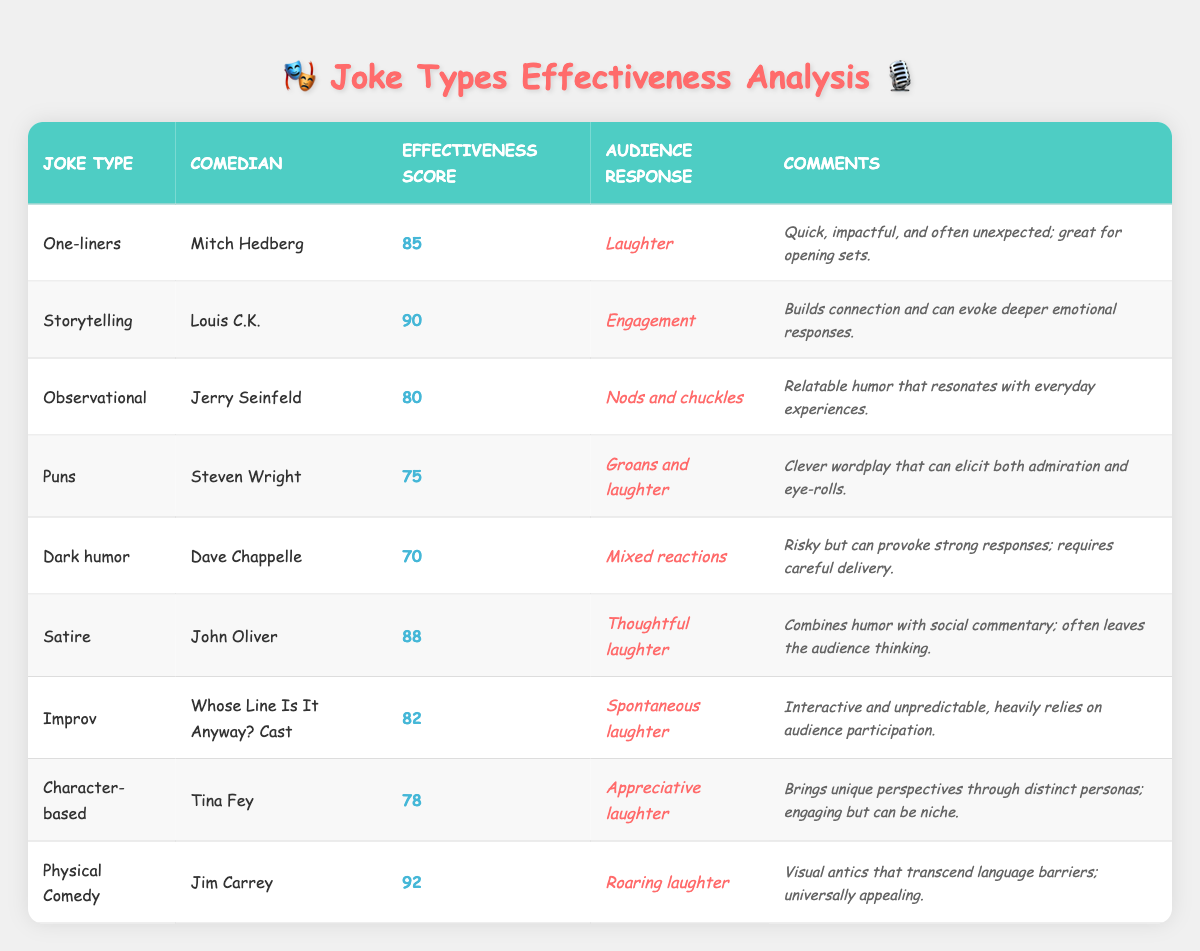What's the effectiveness score for Physical Comedy? The table lists Jim Carrey as the comedian for Physical Comedy, with an effectiveness score of 92.
Answer: 92 Which comedian's jokes evoke engagement from the audience? Louis C.K. is noted for Storytelling, which has an audience response of Engagement according to the table.
Answer: Louis C.K What is the lowest effectiveness score among the joke types? The effectiveness scores for the types are 85, 90, 80, 75, 70, 88, 82, 78, and 92. The lowest score is 70 for Dark humor.
Answer: 70 How many joke types have an effectiveness score above 80? The joke types with scores above 80 are One-liners (85), Storytelling (90), Satire (88), Improv (82), and Physical Comedy (92), totaling 5 types.
Answer: 5 Does Dark humor generally provoke strong audience reactions? The audience response for Dark humor states "Mixed reactions," indicating it does not consistently provoke strong reactions. Hence, it would be false to say it generally does so.
Answer: No Which type of jokes received the highest audience response? Physical Comedy, with an effectiveness score of 92, received "Roaring laughter" as the audience response, which is the highest noted among all types.
Answer: Roaring laughter What is the average effectiveness score of the joke types listed in the table? The total effectiveness scores are 85 + 90 + 80 + 75 + 70 + 88 + 82 + 78 + 92 = 830. There are 9 joke types, so the average is 830/9 = approximately 92.22.
Answer: 92.22 Which comedian is known for clever wordplay, and what is their effectiveness score? Steven Wright is recognized for Puns, which has an effectiveness score of 75, according to the table.
Answer: Steven Wright, 75 How many comedy types resulted in "Laughter" as the audience response? One-liners and Puns both have "Laughter" as their audience response, so there are 2 types.
Answer: 2 What could be inferred about the effectiveness of Improv compared to Character-based comedy? Improv has an effectiveness score of 82 while Character-based comedy has a score of 78, indicating that Improv is generally more effective based on these scores.
Answer: Improv is more effective 